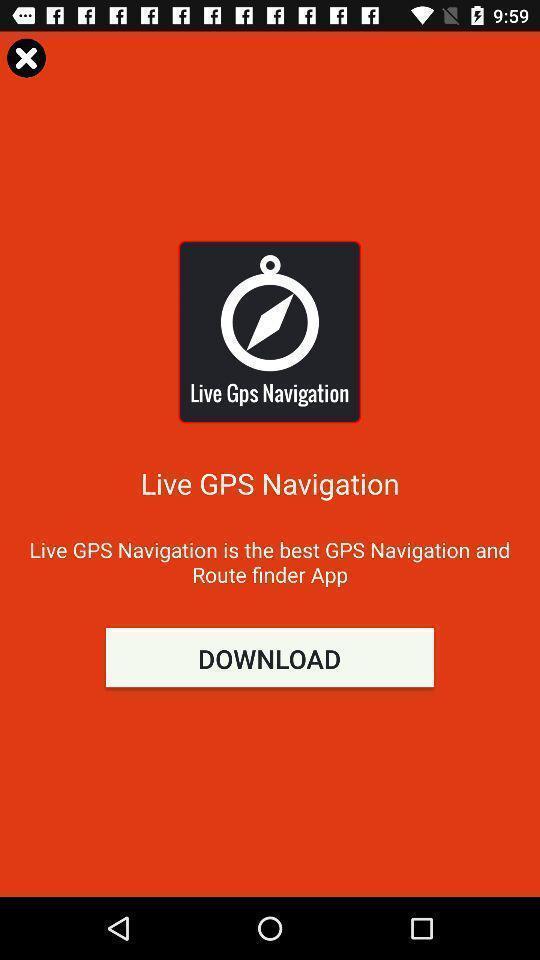Describe this image in words. Push up for downloading an app. 